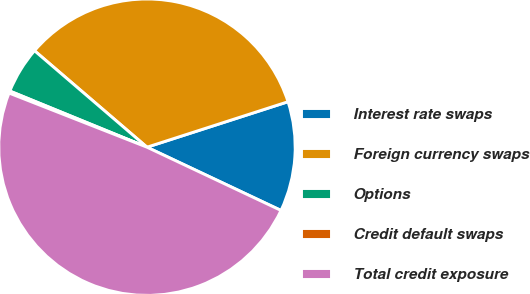<chart> <loc_0><loc_0><loc_500><loc_500><pie_chart><fcel>Interest rate swaps<fcel>Foreign currency swaps<fcel>Options<fcel>Credit default swaps<fcel>Total credit exposure<nl><fcel>11.98%<fcel>33.75%<fcel>5.1%<fcel>0.23%<fcel>48.93%<nl></chart> 